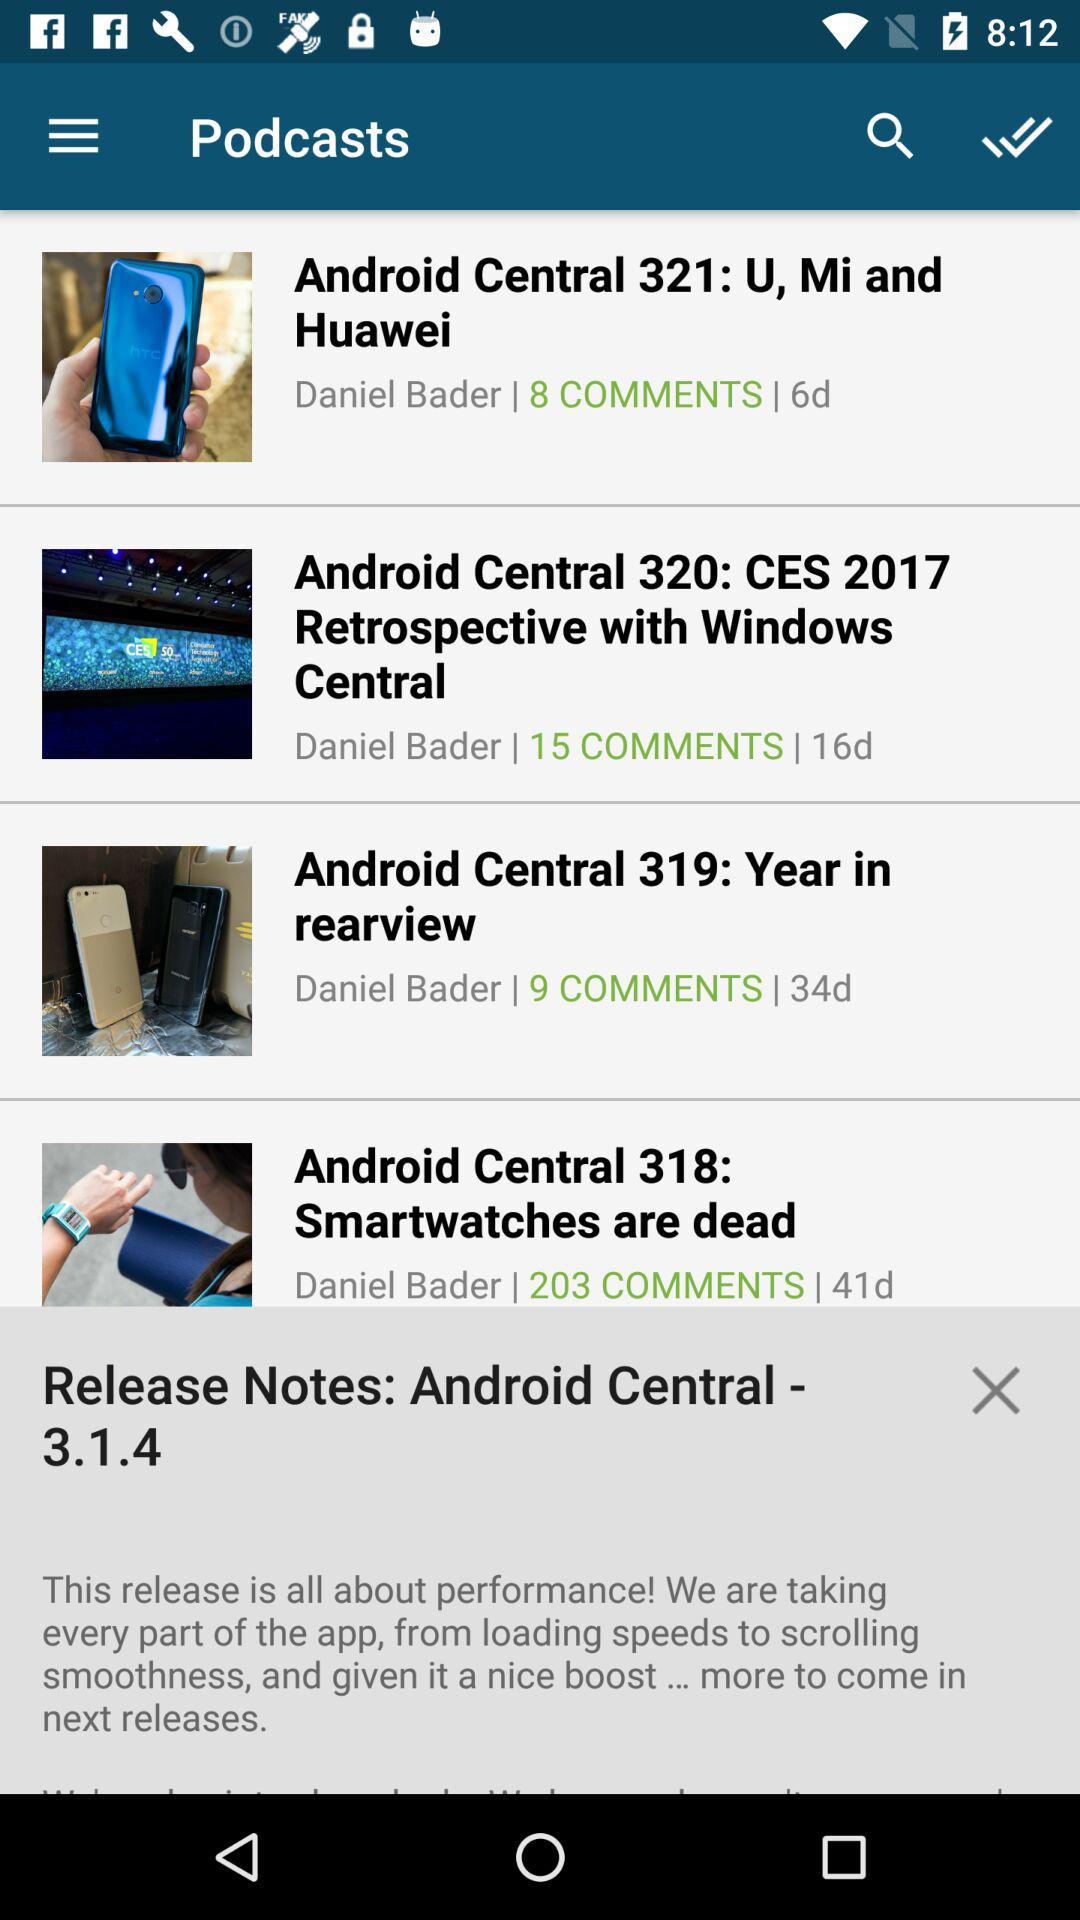What is the number of comments on the topic "Android Central 318: Smartwatches are dead"? The number of comments is 203. 